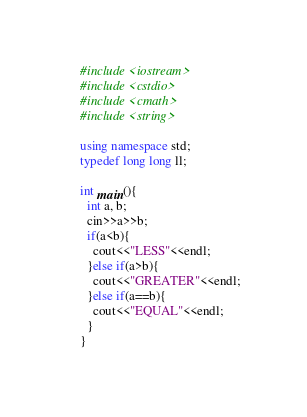<code> <loc_0><loc_0><loc_500><loc_500><_C++_>#include <iostream>
#include <cstdio>
#include <cmath>
#include <string>

using namespace std;
typedef long long ll;

int main(){
  int a, b;
  cin>>a>>b;
  if(a<b){
    cout<<"LESS"<<endl;
  }else if(a>b){
    cout<<"GREATER"<<endl;
  }else if(a==b){
    cout<<"EQUAL"<<endl;
  }
}</code> 